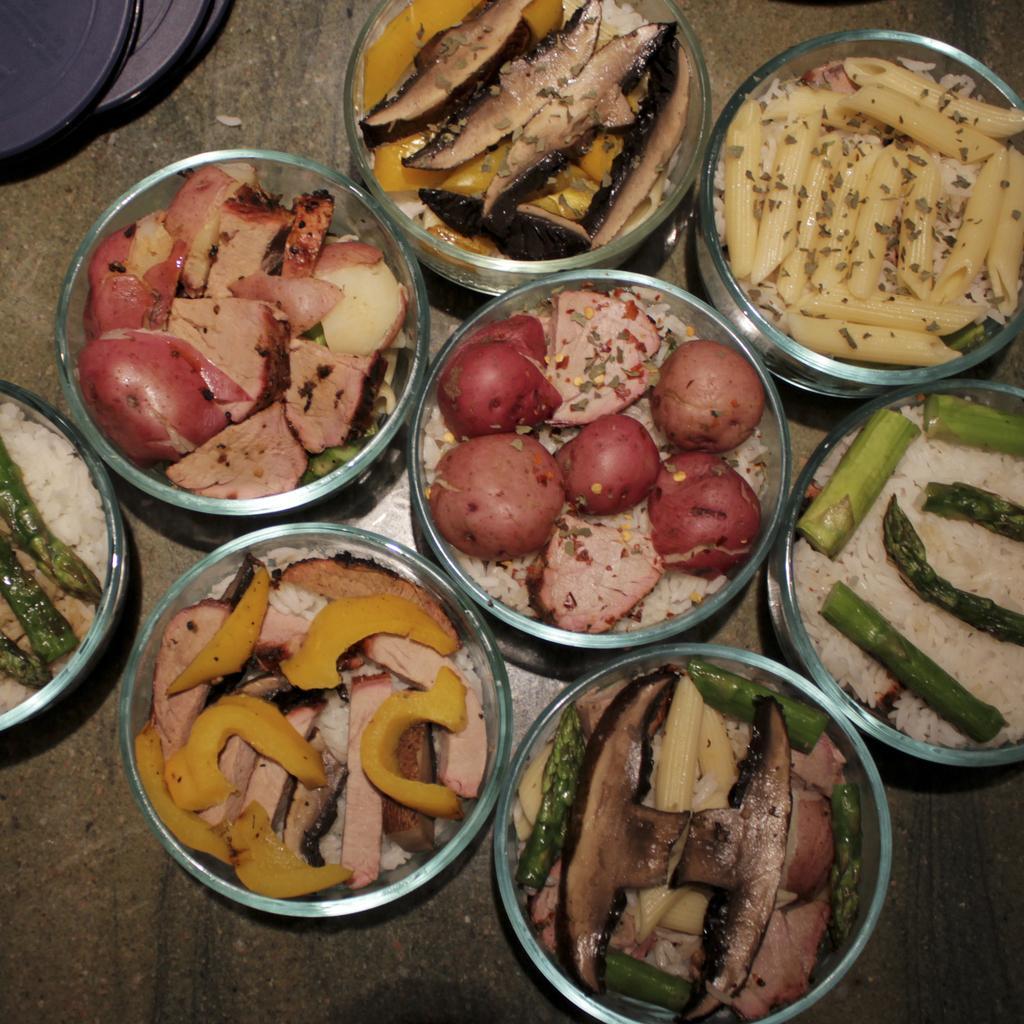Please provide a concise description of this image. This image consists of so many bowls. There are eatables in those bowls. There are meat, pasta, rice, potatoes. 